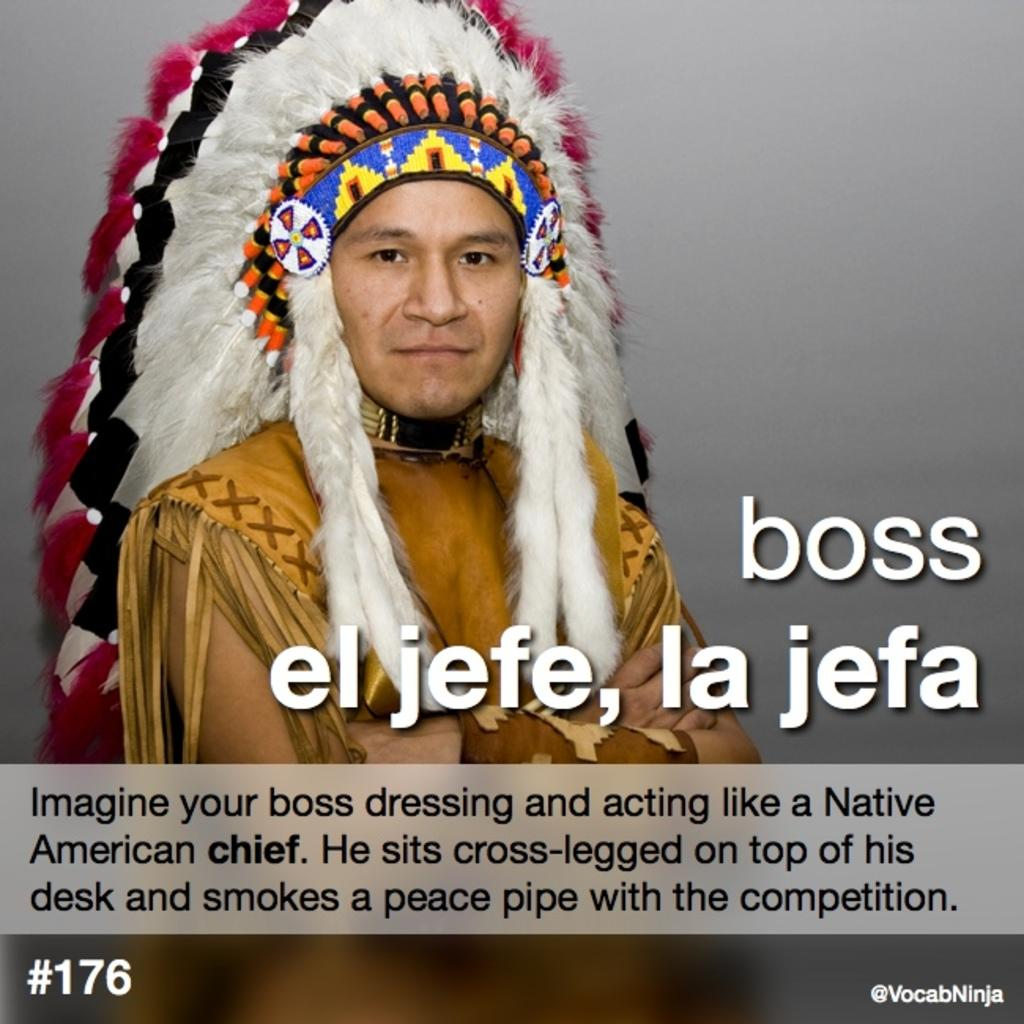What is featured on the poster in the image? There is a poster in the image, and it has a picture of a person. What is the person in the poster wearing? The person in the poster is wearing a cap. What can be found on the front side of the image? There is text on the front side of the image. What is visible in the background of the image? There is a wall in the background of the image. What year is the person in the poster attempting to predict in the image? There is no indication of a year or any attempt to predict a year in the image. 